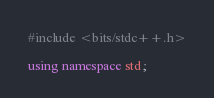<code> <loc_0><loc_0><loc_500><loc_500><_C++_>#include <bits/stdc++.h>

using namespace std;
</code> 